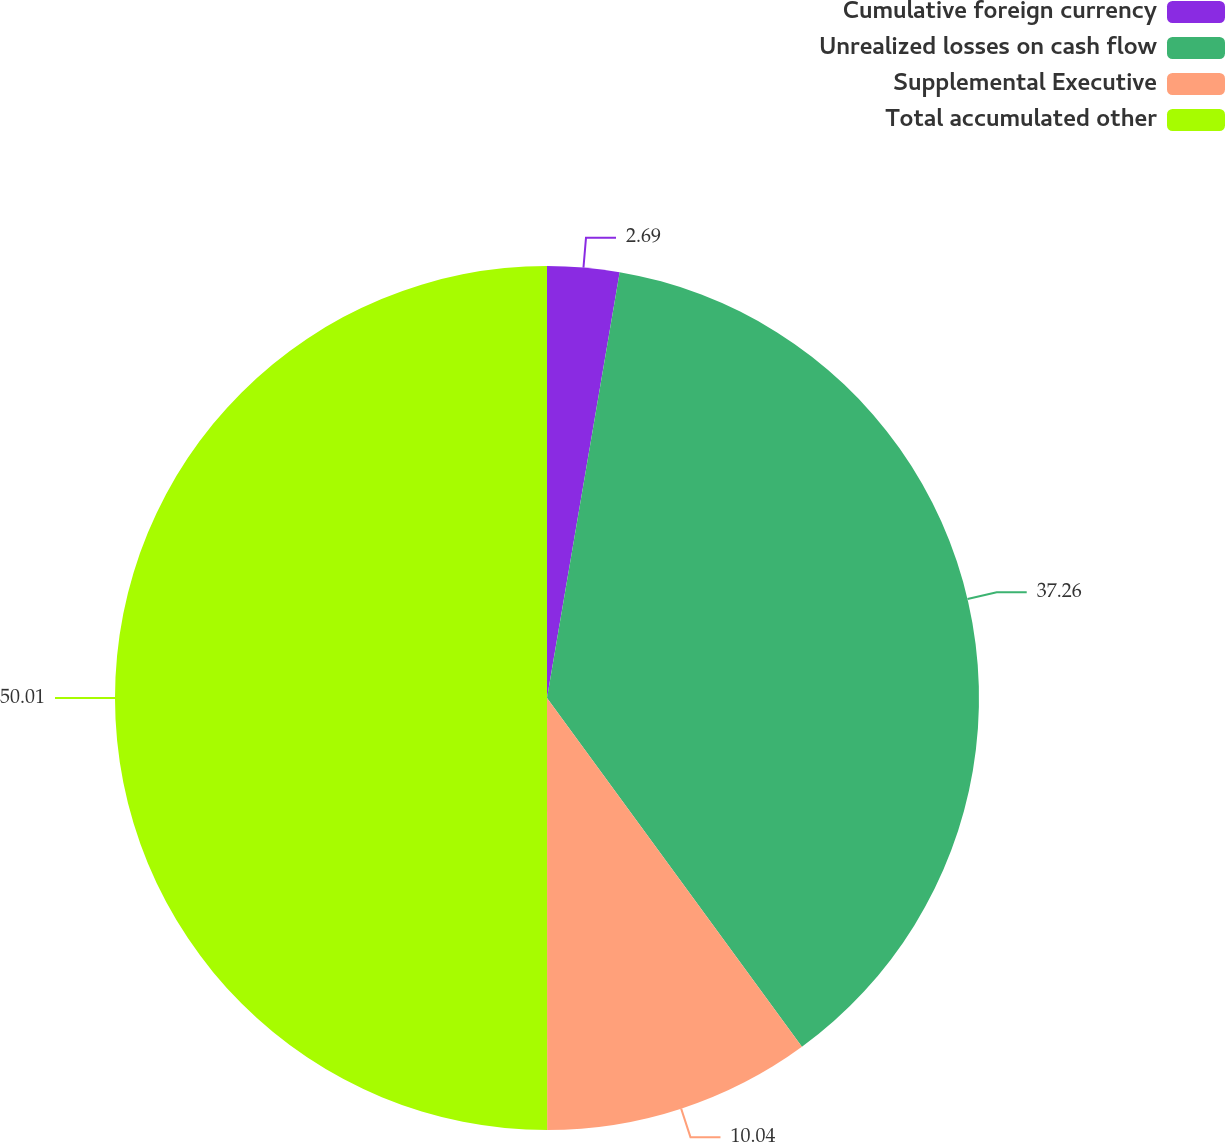Convert chart to OTSL. <chart><loc_0><loc_0><loc_500><loc_500><pie_chart><fcel>Cumulative foreign currency<fcel>Unrealized losses on cash flow<fcel>Supplemental Executive<fcel>Total accumulated other<nl><fcel>2.69%<fcel>37.26%<fcel>10.04%<fcel>50.0%<nl></chart> 